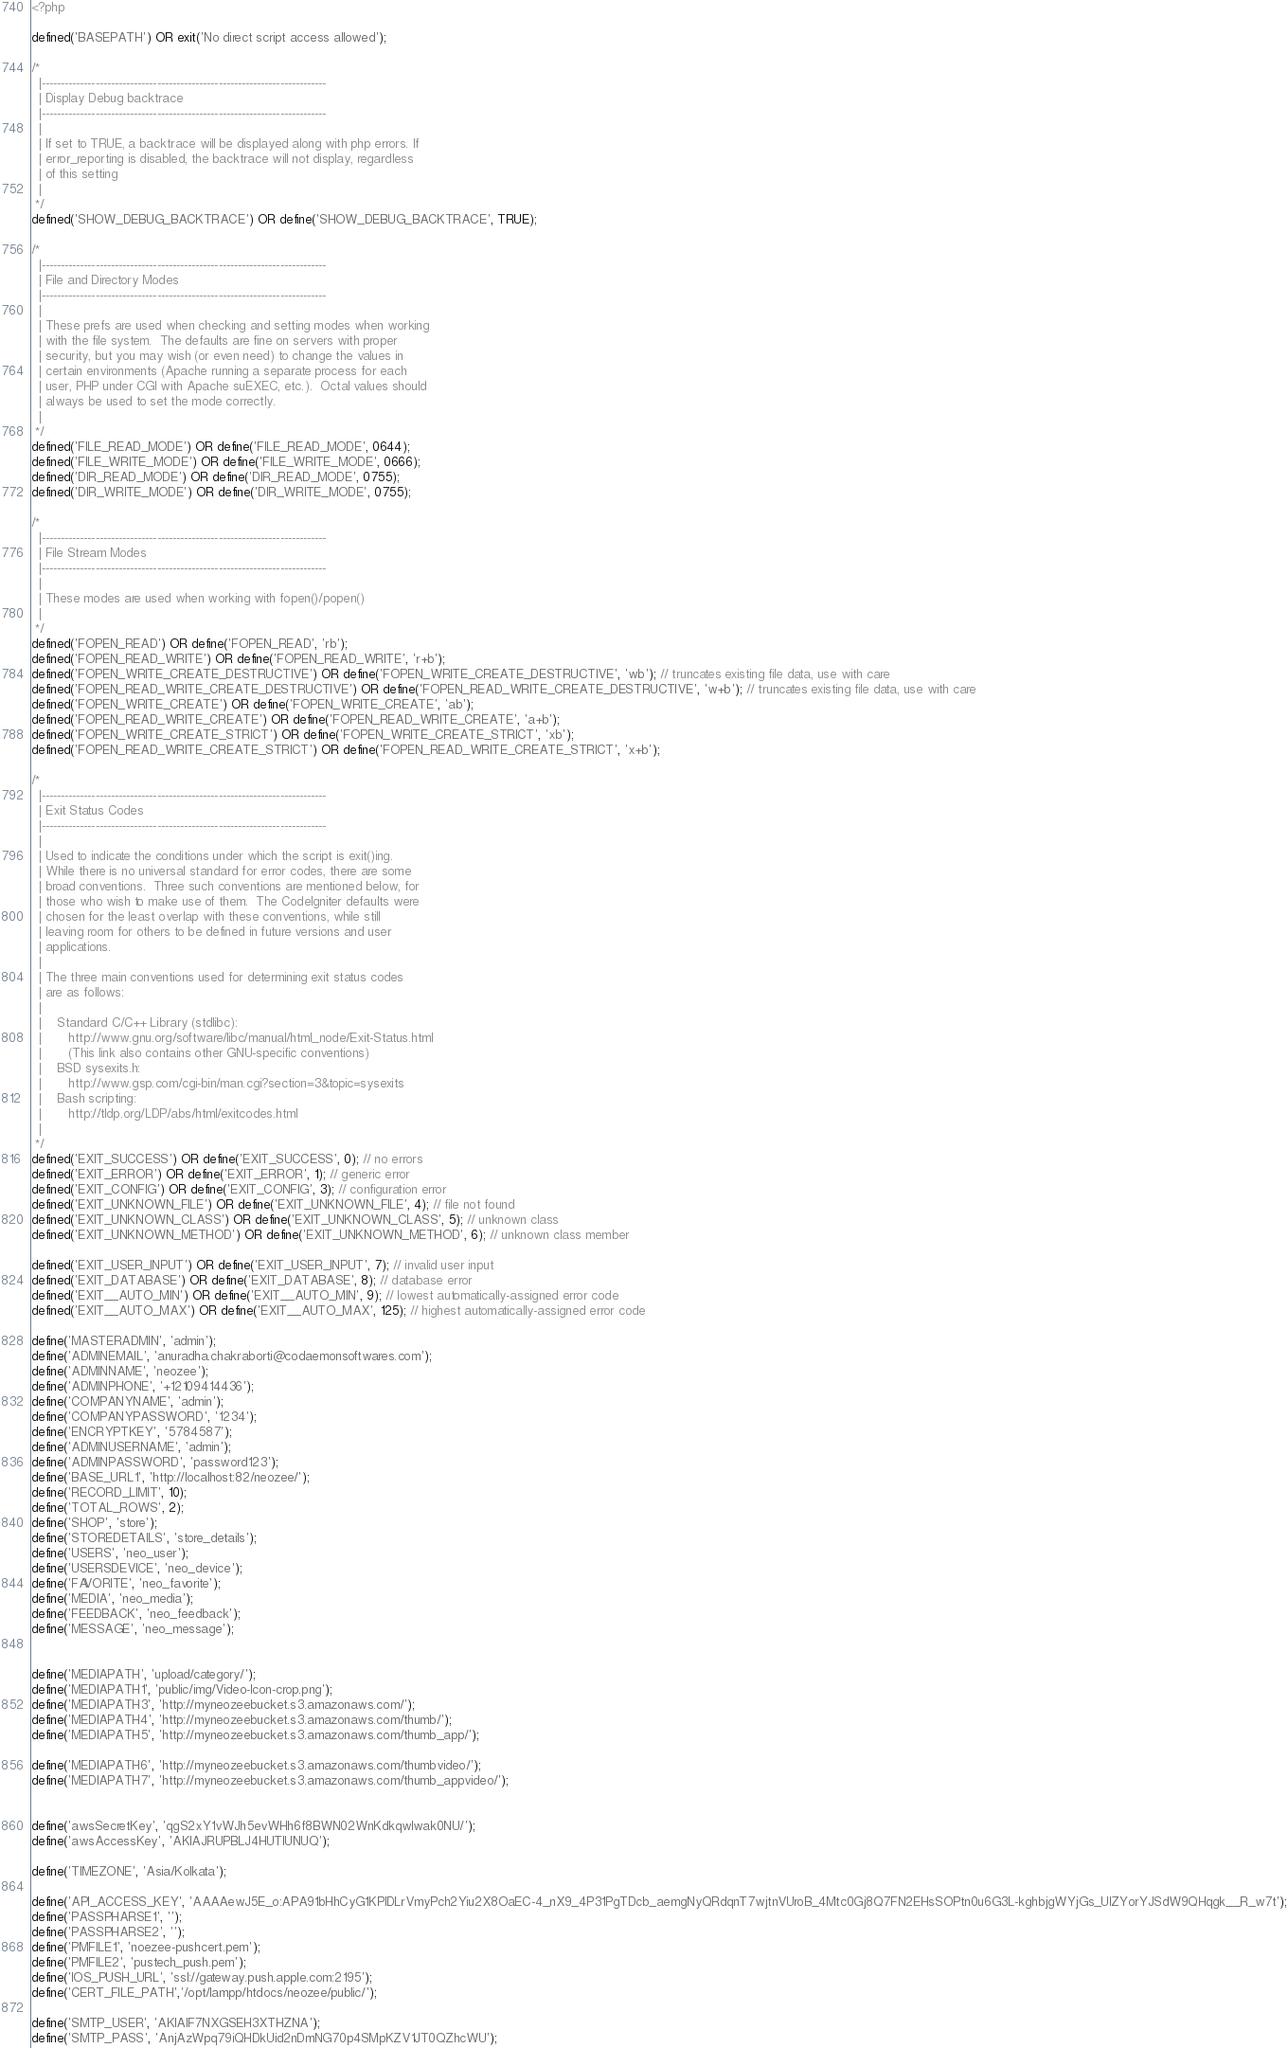Convert code to text. <code><loc_0><loc_0><loc_500><loc_500><_PHP_><?php

defined('BASEPATH') OR exit('No direct script access allowed');

/*
  |--------------------------------------------------------------------------
  | Display Debug backtrace
  |--------------------------------------------------------------------------
  |
  | If set to TRUE, a backtrace will be displayed along with php errors. If
  | error_reporting is disabled, the backtrace will not display, regardless
  | of this setting
  |
 */
defined('SHOW_DEBUG_BACKTRACE') OR define('SHOW_DEBUG_BACKTRACE', TRUE);

/*
  |--------------------------------------------------------------------------
  | File and Directory Modes
  |--------------------------------------------------------------------------
  |
  | These prefs are used when checking and setting modes when working
  | with the file system.  The defaults are fine on servers with proper
  | security, but you may wish (or even need) to change the values in
  | certain environments (Apache running a separate process for each
  | user, PHP under CGI with Apache suEXEC, etc.).  Octal values should
  | always be used to set the mode correctly.
  |
 */
defined('FILE_READ_MODE') OR define('FILE_READ_MODE', 0644);
defined('FILE_WRITE_MODE') OR define('FILE_WRITE_MODE', 0666);
defined('DIR_READ_MODE') OR define('DIR_READ_MODE', 0755);
defined('DIR_WRITE_MODE') OR define('DIR_WRITE_MODE', 0755);

/*
  |--------------------------------------------------------------------------
  | File Stream Modes
  |--------------------------------------------------------------------------
  |
  | These modes are used when working with fopen()/popen()
  |
 */
defined('FOPEN_READ') OR define('FOPEN_READ', 'rb');
defined('FOPEN_READ_WRITE') OR define('FOPEN_READ_WRITE', 'r+b');
defined('FOPEN_WRITE_CREATE_DESTRUCTIVE') OR define('FOPEN_WRITE_CREATE_DESTRUCTIVE', 'wb'); // truncates existing file data, use with care
defined('FOPEN_READ_WRITE_CREATE_DESTRUCTIVE') OR define('FOPEN_READ_WRITE_CREATE_DESTRUCTIVE', 'w+b'); // truncates existing file data, use with care
defined('FOPEN_WRITE_CREATE') OR define('FOPEN_WRITE_CREATE', 'ab');
defined('FOPEN_READ_WRITE_CREATE') OR define('FOPEN_READ_WRITE_CREATE', 'a+b');
defined('FOPEN_WRITE_CREATE_STRICT') OR define('FOPEN_WRITE_CREATE_STRICT', 'xb');
defined('FOPEN_READ_WRITE_CREATE_STRICT') OR define('FOPEN_READ_WRITE_CREATE_STRICT', 'x+b');

/*
  |--------------------------------------------------------------------------
  | Exit Status Codes
  |--------------------------------------------------------------------------
  |
  | Used to indicate the conditions under which the script is exit()ing.
  | While there is no universal standard for error codes, there are some
  | broad conventions.  Three such conventions are mentioned below, for
  | those who wish to make use of them.  The CodeIgniter defaults were
  | chosen for the least overlap with these conventions, while still
  | leaving room for others to be defined in future versions and user
  | applications.
  |
  | The three main conventions used for determining exit status codes
  | are as follows:
  |
  |    Standard C/C++ Library (stdlibc):
  |       http://www.gnu.org/software/libc/manual/html_node/Exit-Status.html
  |       (This link also contains other GNU-specific conventions)
  |    BSD sysexits.h:
  |       http://www.gsp.com/cgi-bin/man.cgi?section=3&topic=sysexits
  |    Bash scripting:
  |       http://tldp.org/LDP/abs/html/exitcodes.html
  |
 */
defined('EXIT_SUCCESS') OR define('EXIT_SUCCESS', 0); // no errors
defined('EXIT_ERROR') OR define('EXIT_ERROR', 1); // generic error
defined('EXIT_CONFIG') OR define('EXIT_CONFIG', 3); // configuration error
defined('EXIT_UNKNOWN_FILE') OR define('EXIT_UNKNOWN_FILE', 4); // file not found
defined('EXIT_UNKNOWN_CLASS') OR define('EXIT_UNKNOWN_CLASS', 5); // unknown class
defined('EXIT_UNKNOWN_METHOD') OR define('EXIT_UNKNOWN_METHOD', 6); // unknown class member

defined('EXIT_USER_INPUT') OR define('EXIT_USER_INPUT', 7); // invalid user input
defined('EXIT_DATABASE') OR define('EXIT_DATABASE', 8); // database error
defined('EXIT__AUTO_MIN') OR define('EXIT__AUTO_MIN', 9); // lowest automatically-assigned error code
defined('EXIT__AUTO_MAX') OR define('EXIT__AUTO_MAX', 125); // highest automatically-assigned error code

define('MASTERADMIN', 'admin');
define('ADMINEMAIL', 'anuradha.chakraborti@codaemonsoftwares.com');
define('ADMINNAME', 'neozee');
define('ADMINPHONE', '+12109414436');
define('COMPANYNAME', 'admin');
define('COMPANYPASSWORD', '1234');
define('ENCRYPTKEY', '5784587');
define('ADMINUSERNAME', 'admin');
define('ADMINPASSWORD', 'password123');
define('BASE_URL1', 'http://localhost:82/neozee/');
define('RECORD_LIMIT', 10);
define('TOTAL_ROWS', 2);
define('SHOP', 'store');
define('STOREDETAILS', 'store_details');
define('USERS', 'neo_user');
define('USERSDEVICE', 'neo_device');
define('FAVORITE', 'neo_favorite');
define('MEDIA', 'neo_media');
define('FEEDBACK', 'neo_feedback');
define('MESSAGE', 'neo_message');


define('MEDIAPATH', 'upload/category/');
define('MEDIAPATH1', 'public/img/Video-Icon-crop.png');
define('MEDIAPATH3', 'http://myneozeebucket.s3.amazonaws.com/');
define('MEDIAPATH4', 'http://myneozeebucket.s3.amazonaws.com/thumb/');
define('MEDIAPATH5', 'http://myneozeebucket.s3.amazonaws.com/thumb_app/');

define('MEDIAPATH6', 'http://myneozeebucket.s3.amazonaws.com/thumbvideo/');
define('MEDIAPATH7', 'http://myneozeebucket.s3.amazonaws.com/thumb_appvideo/');


define('awsSecretKey', 'qgS2xY1vWJh5evWHh6f8BWN02WnKdkqwlwak0NU/');
define('awsAccessKey', 'AKIAJRUPBLJ4HUTIUNUQ');

define('TIMEZONE', 'Asia/Kolkata');

define('API_ACCESS_KEY', 'AAAAewJ5E_o:APA91bHhCyG1KPlDLrVmyPch2Yiu2X8OaEC-4_nX9_4P31PgTDcb_aemgNyQRdqnT7wjtnVUroB_4Mtc0Gj8Q7FN2EHsSOPtn0u6G3L-kghbjgWYjGs_UIZYorYJSdW9QHqgk__R_w7t');
define('PASSPHARSE1', '');
define('PASSPHARSE2', '');
define('PMFILE1', 'noezee-pushcert.pem');
define('PMFILE2', 'pustech_push.pem');
define('IOS_PUSH_URL', 'ssl://gateway.push.apple.com:2195');
define('CERT_FILE_PATH','/opt/lampp/htdocs/neozee/public/');

define('SMTP_USER', 'AKIAIF7NXGSEH3XTHZNA');
define('SMTP_PASS', 'AnjAzWpq79iQHDkUid2nDmNG70p4SMpKZV1JT0QZhcWU');</code> 